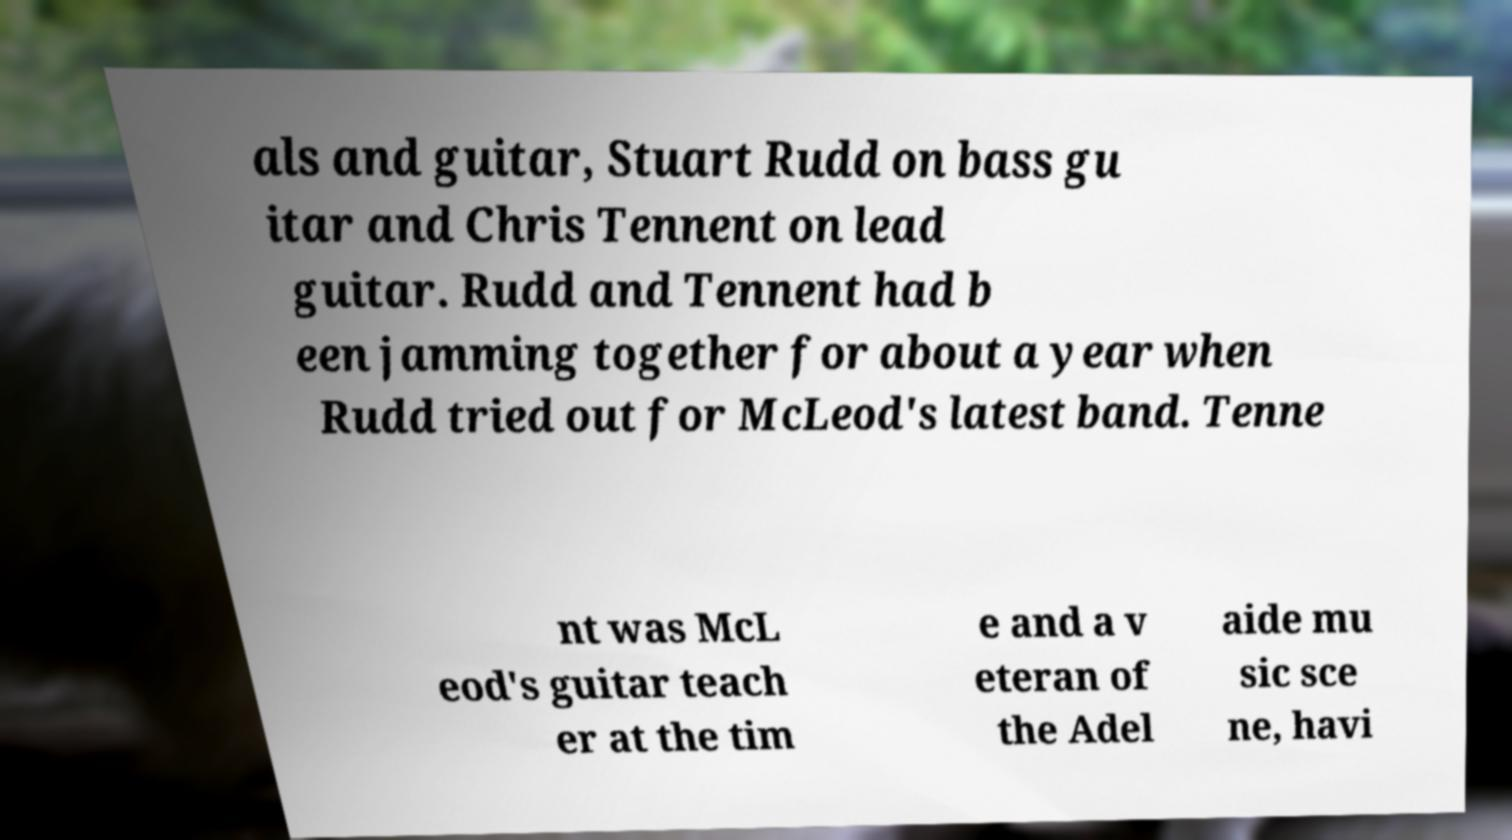Could you assist in decoding the text presented in this image and type it out clearly? als and guitar, Stuart Rudd on bass gu itar and Chris Tennent on lead guitar. Rudd and Tennent had b een jamming together for about a year when Rudd tried out for McLeod's latest band. Tenne nt was McL eod's guitar teach er at the tim e and a v eteran of the Adel aide mu sic sce ne, havi 